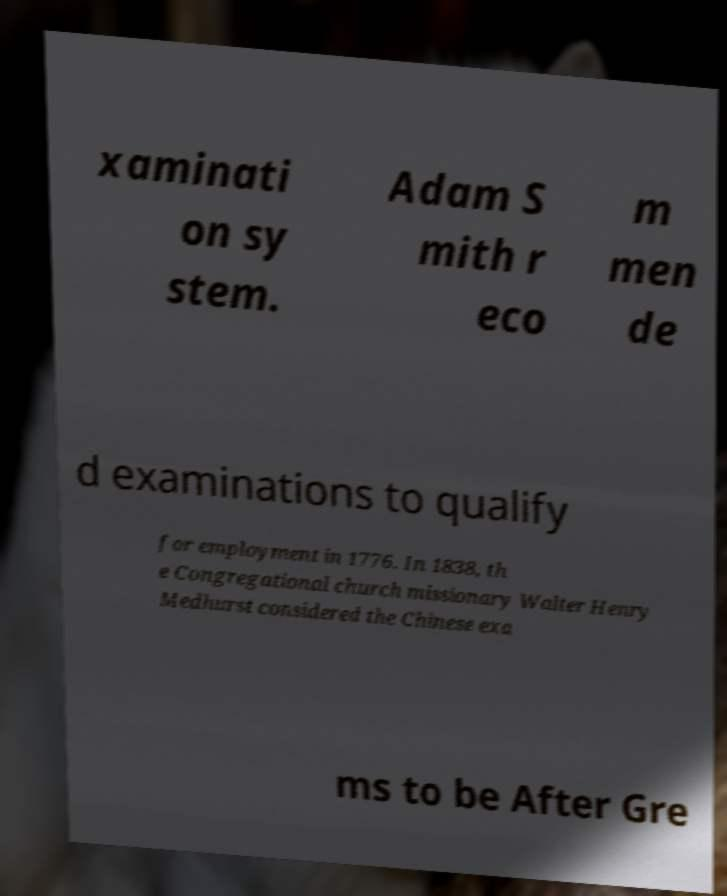Can you read and provide the text displayed in the image?This photo seems to have some interesting text. Can you extract and type it out for me? xaminati on sy stem. Adam S mith r eco m men de d examinations to qualify for employment in 1776. In 1838, th e Congregational church missionary Walter Henry Medhurst considered the Chinese exa ms to be After Gre 